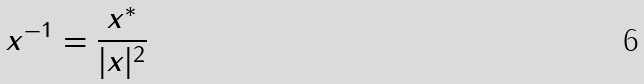<formula> <loc_0><loc_0><loc_500><loc_500>x ^ { - 1 } = \frac { x ^ { * } } { | x | ^ { 2 } }</formula> 